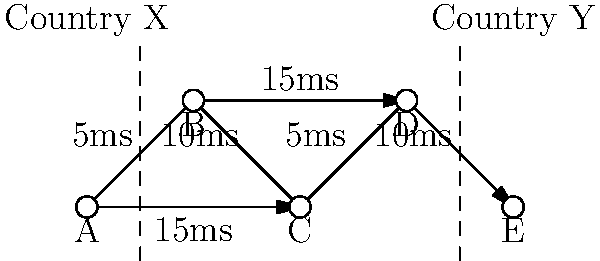Given the network topology shown above representing cross-border data transfer between Country X and Country Y, what is the optimal path from node A to node E that minimizes latency while ensuring data passes through both countries? Calculate the total latency of this optimal path. To solve this problem, we need to consider all possible paths from A to E that pass through both countries, and calculate their latencies:

1. Path A-B-C-D-E:
   - Passes through both countries
   - Latency = 5ms + 10ms + 5ms + 10ms = 30ms

2. Path A-C-D-E:
   - Passes through both countries
   - Latency = 15ms + 5ms + 10ms = 30ms

3. Path A-B-D-E:
   - Passes through both countries
   - Latency = 5ms + 15ms + 10ms = 30ms

All three paths have the same total latency of 30ms. However, the question asks for the optimal path, so we need to consider other factors:

1. Path A-B-C-D-E has the most hops (4), which could potentially introduce more points of failure.
2. Paths A-C-D-E and A-B-D-E both have 3 hops, making them more efficient in terms of the number of network devices the data needs to pass through.

Between A-C-D-E and A-B-D-E, we can choose A-B-D-E as the optimal path because:
- It starts with a lower latency link (5ms vs 15ms), which could be beneficial for initial packet transmission.
- It may provide better load balancing by utilizing both the upper and lower links of the network.

Therefore, the optimal path is A-B-D-E, with a total latency of 30ms.
Answer: A-B-D-E, 30ms 